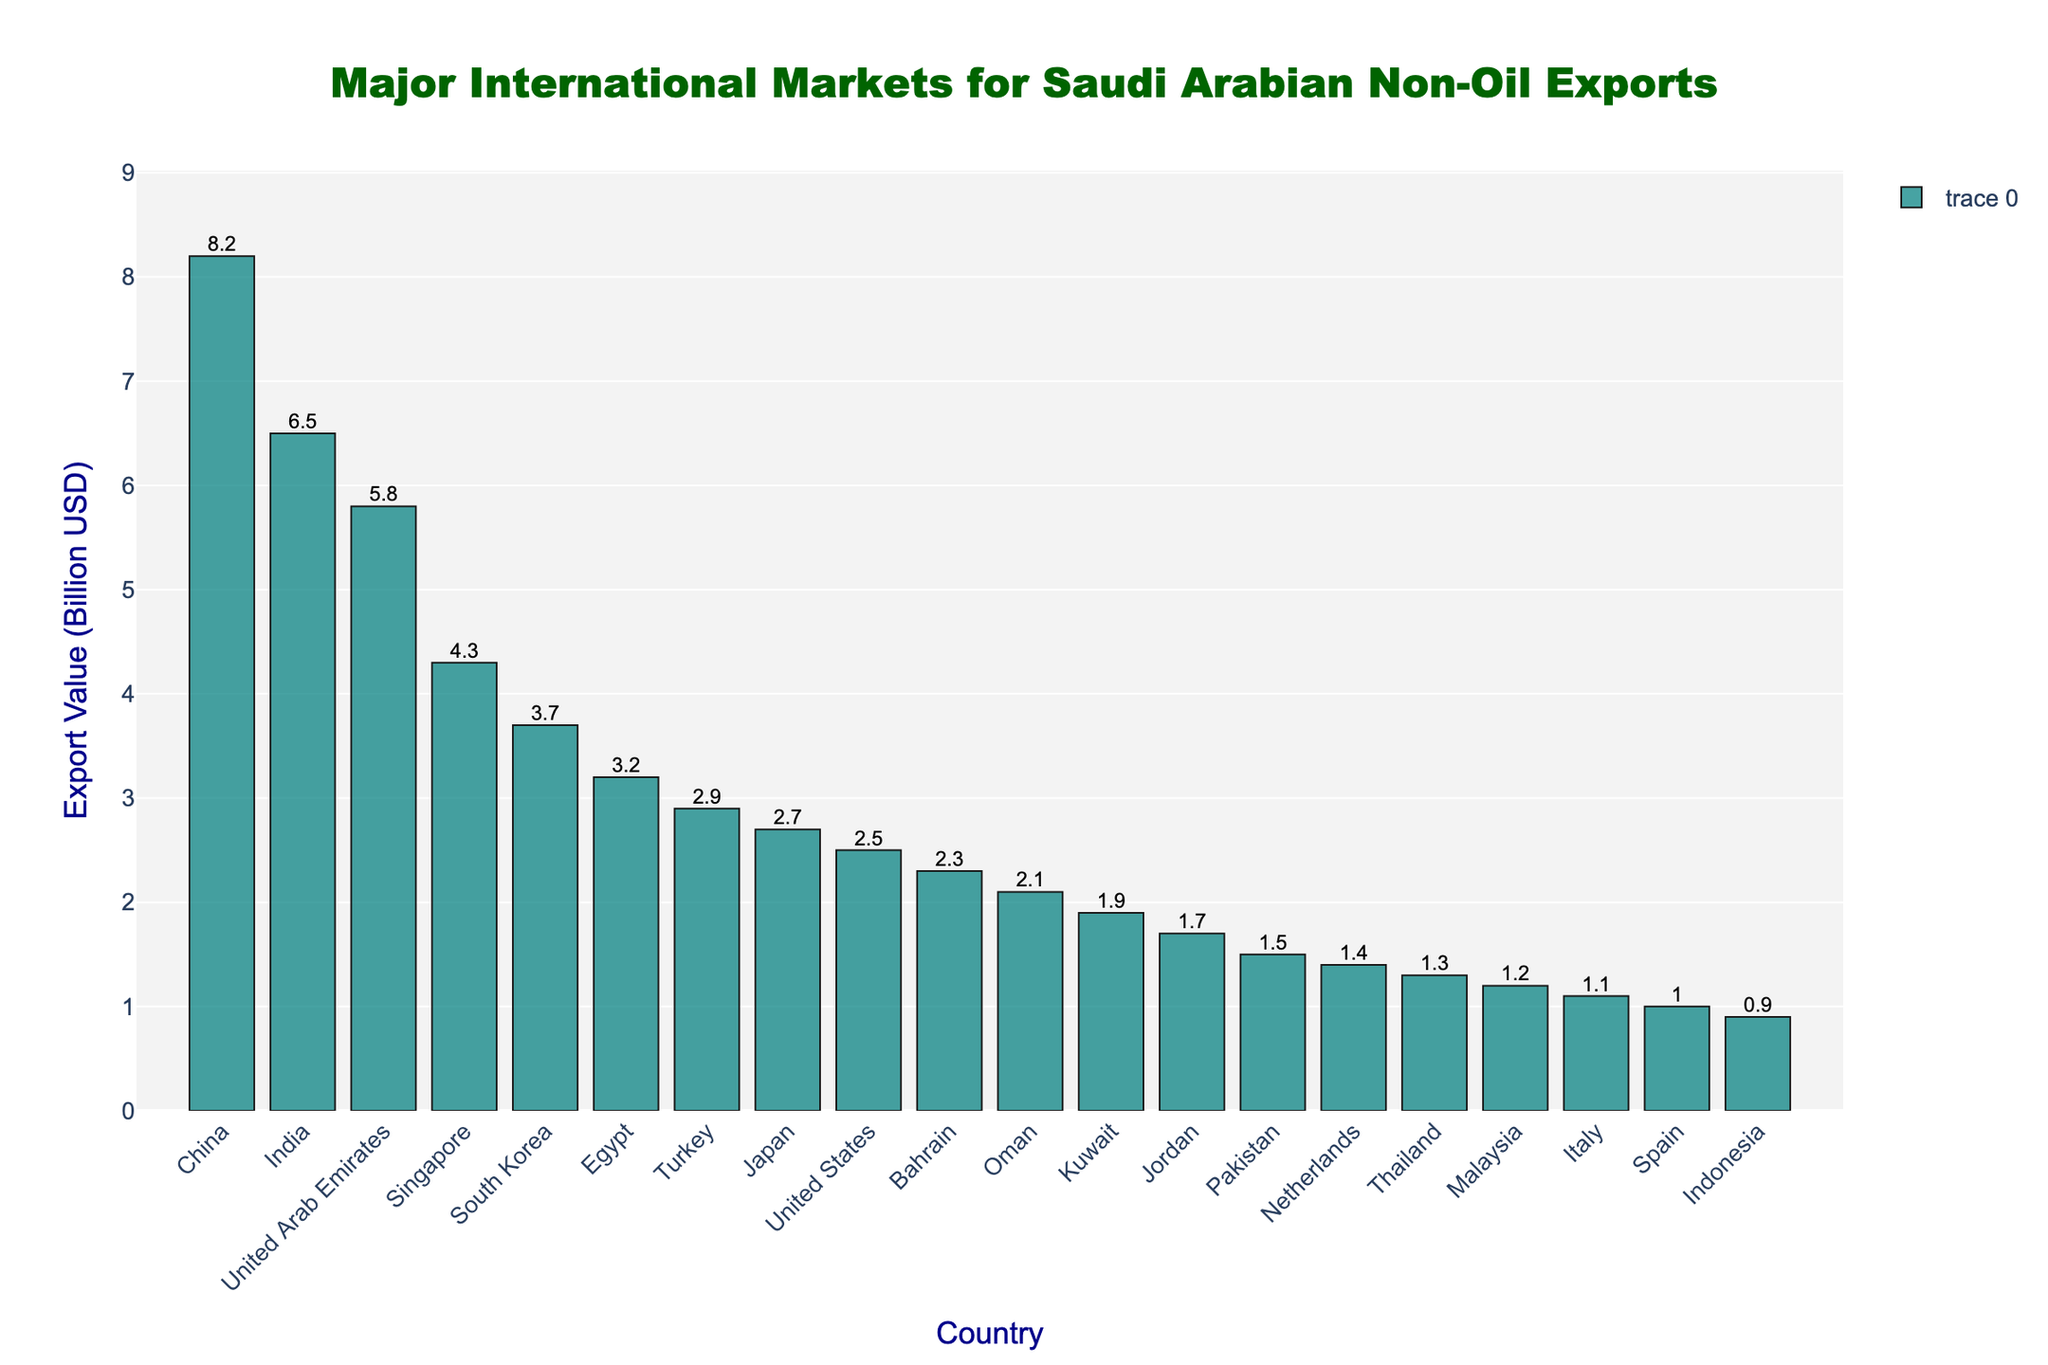What is the total export value to China and India combined? The export value to China is 8.2 billion USD and to India is 6.5 billion USD. Adding these together gives 8.2 + 6.5 = 14.7 billion USD
Answer: 14.7 Which country imports more: Egypt or Turkey? The export value to Egypt is 3.2 billion USD and to Turkey is 2.9 billion USD. Since 3.2 is greater than 2.9, Egypt imports more.
Answer: Egypt What is the difference in export value between South Korea and Japan? The export value to South Korea is 3.7 billion USD and to Japan is 2.7 billion USD. The difference is 3.7 - 2.7 = 1.0 billion USD
Answer: 1.0 Which country has the lowest export value, and what is the value? Indonesia has the lowest export value of 0.9 billion USD as it is the smallest bar in the chart.
Answer: Indonesia, 0.9 What is the sum of export values for countries from the Middle East (United Arab Emirates, Bahrain, Oman, Kuwait, Jordan)? The values are: United Arab Emirates (5.8), Bahrain (2.3), Oman (2.1), Kuwait (1.9), Jordan (1.7). Summing them: 5.8 + 2.3 + 2.1 + 1.9 + 1.7 = 13.8 billion USD
Answer: 13.8 Which countries have export values greater than 5 billion USD? The countries with export values greater than 5 billion USD are China (8.2), India (6.5), and United Arab Emirates (5.8).
Answer: China, India, United Arab Emirates What is the average export value across all the countries listed? Sum of export values: 8.2 + 6.5 + 5.8 + 4.3 + 3.7 + 3.2 + 2.9 + 2.7 + 2.5 + 2.3 + 2.1 + 1.9 + 1.7 + 1.5 + 1.4 + 1.3 + 1.2 + 1.1 + 1.0 + 0.9 = 60.2. Number of countries: 20. Average = 60.2 / 20 = 3.01 billion USD
Answer: 3.01 Does Saudi Arabia export more non-oil products to Japan or to the United States? The export value to Japan is 2.7 billion USD and to the United States is 2.5 billion USD. Since 2.7 is greater than 2.5, more is exported to Japan.
Answer: Japan What is the height of the bar representing Saudi Arabian exports to Singapore relative to those to South Korea? The bar for Singapore is taller since the export value is 4.3 billion USD compared to South Korea's 3.7 billion USD.
Answer: Taller 